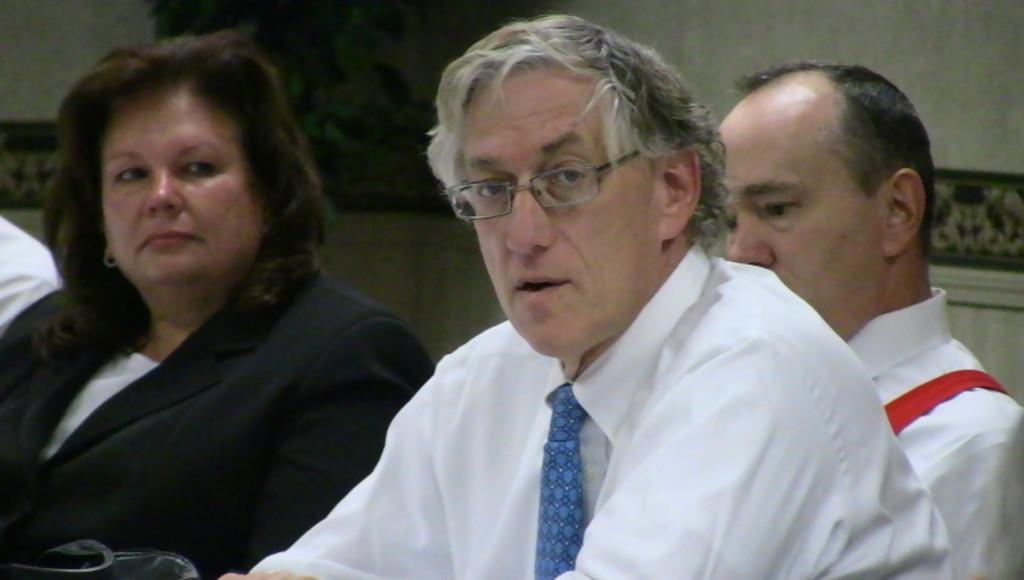Could you give a brief overview of what you see in this image? In this image in the foreground there are some people one person is wearing spectacles, and in the background there is a wall and some photo frame. 